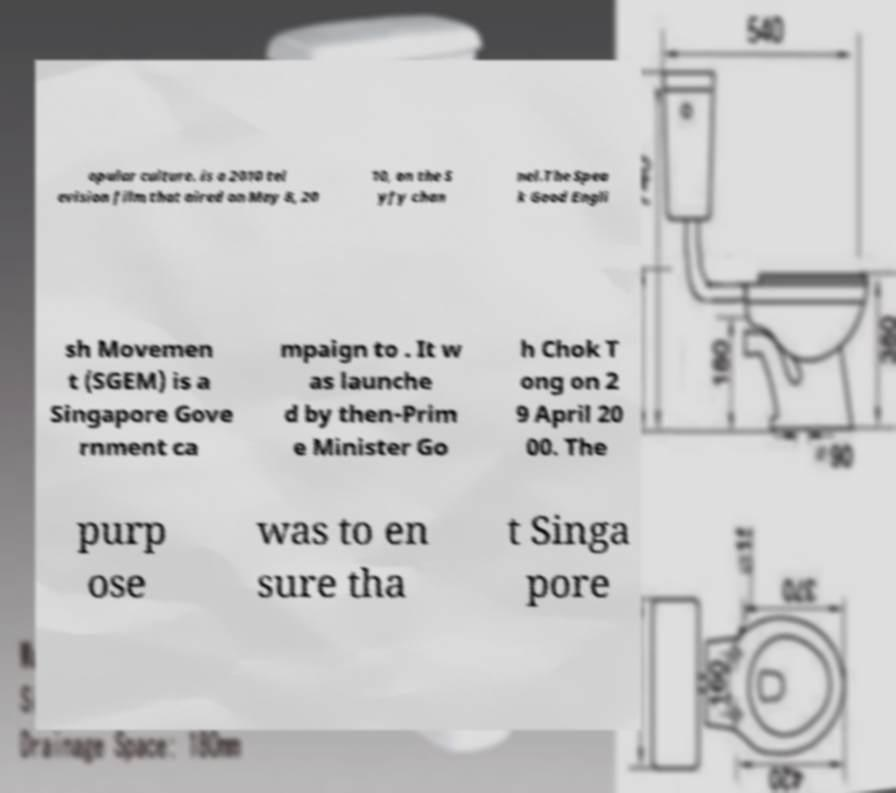Can you accurately transcribe the text from the provided image for me? opular culture. is a 2010 tel evision film that aired on May 8, 20 10, on the S yfy chan nel.The Spea k Good Engli sh Movemen t (SGEM) is a Singapore Gove rnment ca mpaign to . It w as launche d by then-Prim e Minister Go h Chok T ong on 2 9 April 20 00. The purp ose was to en sure tha t Singa pore 